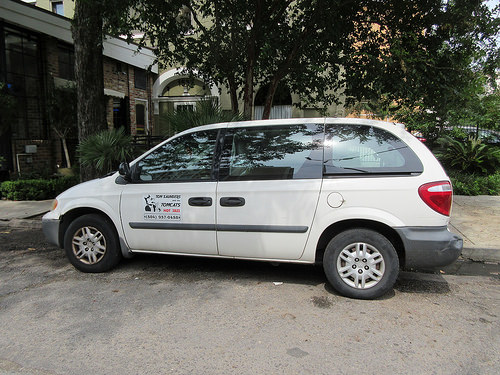<image>
Can you confirm if the van is behind the house? No. The van is not behind the house. From this viewpoint, the van appears to be positioned elsewhere in the scene. Where is the stain in relation to the tire? Is it next to the tire? Yes. The stain is positioned adjacent to the tire, located nearby in the same general area. 